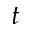<formula> <loc_0><loc_0><loc_500><loc_500>t</formula> 